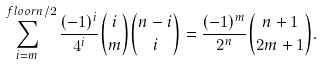<formula> <loc_0><loc_0><loc_500><loc_500>\sum _ { i = m } ^ { \ f l o o r { n / 2 } } \frac { ( - 1 ) ^ { i } } { 4 ^ { i } } \binom { i } { m } \binom { n - i } { i } = \frac { ( - 1 ) ^ { m } } { 2 ^ { n } } \binom { n + 1 } { 2 m + 1 } .</formula> 